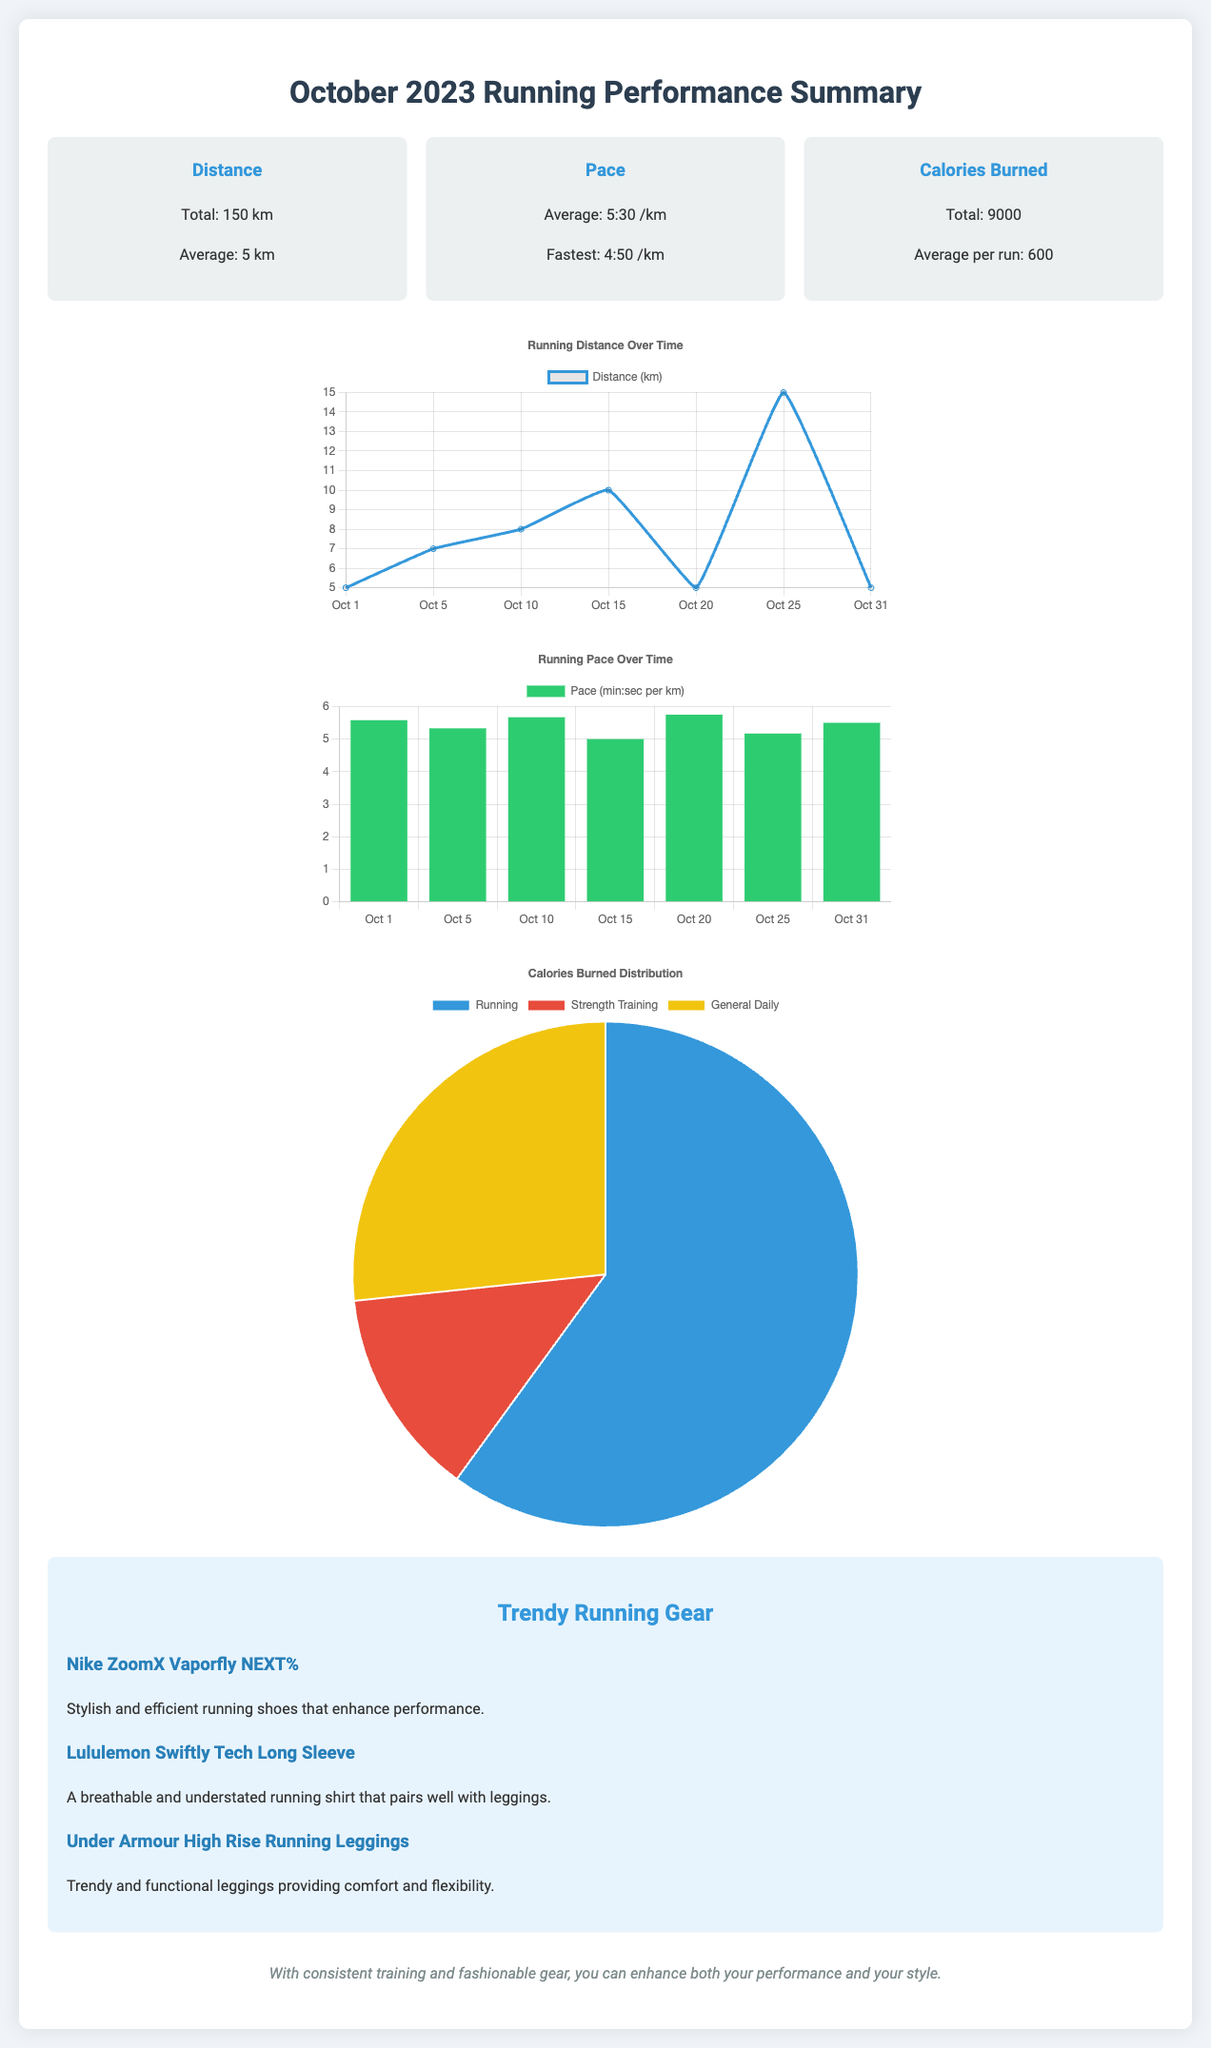What is the total distance run? The total distance run is noted in the summary section of the document.
Answer: 150 km What is the average pace? The average pace is provided in the summary section and refers to the pace per kilometer.
Answer: 5:30 /km How many calories were burned in total? The total calories burned are listed in the summary section of the document.
Answer: 9000 What was the fastest pace recorded? The fastest pace is mentioned in the pace summary and is expressed in minutes per kilometer.
Answer: 4:50 /km Which product is highlighted as stylish and efficient running shoes? The product highlights are listed in the trendy running gear section of the document.
Answer: Nike ZoomX Vaporfly NEXT% What is the average number of calories burned per run? This average is found in the summary section of the document regarding calories burned.
Answer: 600 What type of chart is used to display running distance over time? The type of chart is indicated by the chart's presentation in the document.
Answer: Line chart What does the pace chart represent? The pace chart shows a specific measurement over time, as mentioned in the document.
Answer: Pace (min:sec per km) How many fashion items are listed in the trendy running gear section? The total number of items is mentioned in the trendy running gear part of the document.
Answer: 3 